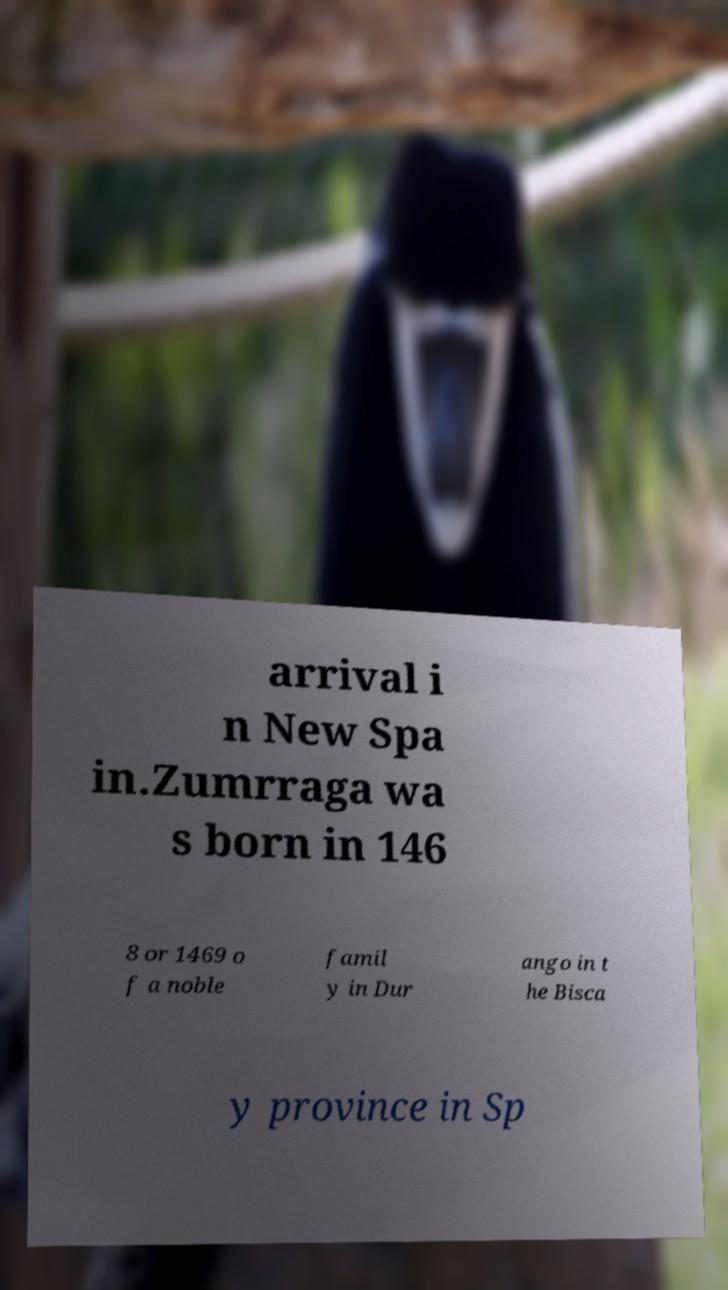Could you assist in decoding the text presented in this image and type it out clearly? arrival i n New Spa in.Zumrraga wa s born in 146 8 or 1469 o f a noble famil y in Dur ango in t he Bisca y province in Sp 